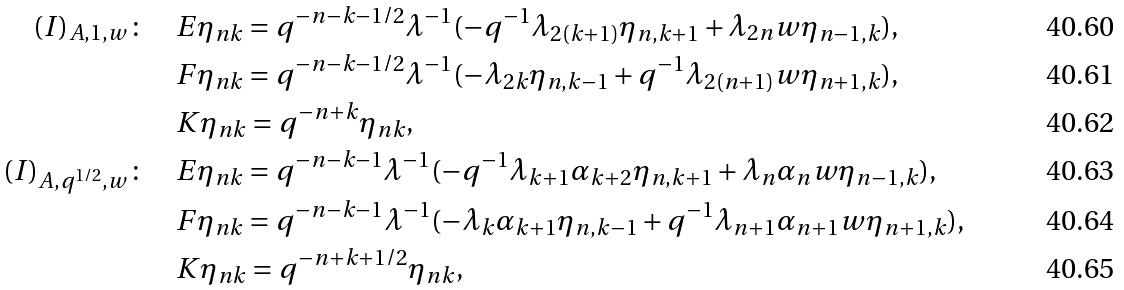Convert formula to latex. <formula><loc_0><loc_0><loc_500><loc_500>( I ) _ { A , 1 , w } \colon \quad & E \eta _ { n k } = q ^ { - n - k - 1 / 2 } \lambda ^ { - 1 } ( - q ^ { - 1 } \lambda _ { 2 ( k + 1 ) } \eta _ { n , k + 1 } + \lambda _ { 2 n } w \eta _ { n - 1 , k } ) , \\ & F \eta _ { n k } = q ^ { - n - k - 1 / 2 } \lambda ^ { - 1 } ( - \lambda _ { 2 k } \eta _ { n , k - 1 } + q ^ { - 1 } \lambda _ { 2 ( n + 1 ) } w \eta _ { n + 1 , k } ) , \\ & K \eta _ { n k } = q ^ { - n + k } \eta _ { n k } , \\ ( I ) _ { A , q ^ { 1 / 2 } , w } \colon \quad & E \eta _ { n k } = q ^ { - n - k - 1 } \lambda ^ { - 1 } ( - q ^ { - 1 } \lambda _ { k + 1 } \alpha _ { k + 2 } \eta _ { n , k + 1 } + \lambda _ { n } \alpha _ { n } w \eta _ { n - 1 , k } ) , \\ & F \eta _ { n k } = q ^ { - n - k - 1 } \lambda ^ { - 1 } ( - \lambda _ { k } \alpha _ { k + 1 } \eta _ { n , k - 1 } + q ^ { - 1 } \lambda _ { n + 1 } \alpha _ { n + 1 } w \eta _ { n + 1 , k } ) , \\ & K \eta _ { n k } = q ^ { - n + k + 1 / 2 } \eta _ { n k } ,</formula> 